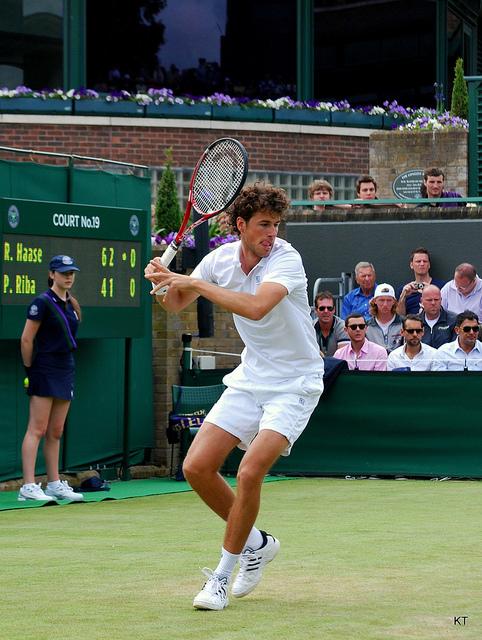What technique is being demonstrated?
Keep it brief. Swing. Scale of 1-10, to what extent does the man in white resemble David Hasselhoff?
Keep it brief. 7. What brand of tennis racket does the man have?
Quick response, please. Wilson. Are there flowers in the background?
Write a very short answer. Yes. How many people are wearing sunglasses?
Concise answer only. 4. What sport are the men playing?
Concise answer only. Tennis. Has the player hit the ball?
Quick response, please. No. Is the man going to hit the ball?
Answer briefly. Yes. What is this player doing?
Short answer required. Tennis. Is this a professional game?
Short answer required. Yes. 